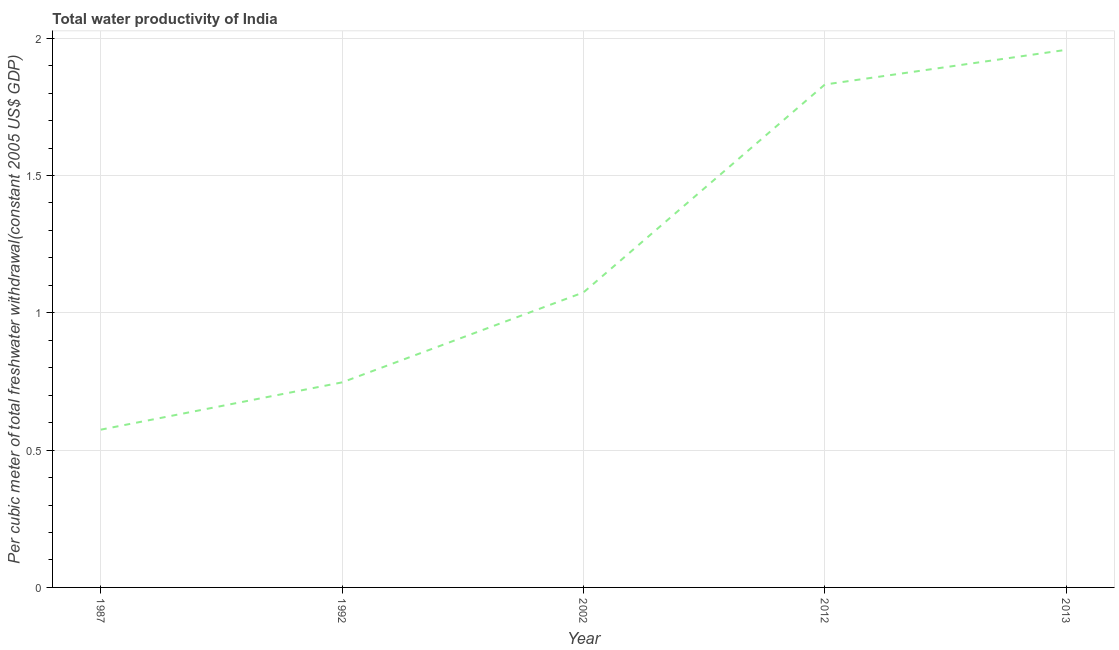What is the total water productivity in 2002?
Offer a very short reply. 1.07. Across all years, what is the maximum total water productivity?
Your answer should be compact. 1.96. Across all years, what is the minimum total water productivity?
Offer a terse response. 0.57. In which year was the total water productivity maximum?
Your answer should be compact. 2013. What is the sum of the total water productivity?
Provide a short and direct response. 6.18. What is the difference between the total water productivity in 2002 and 2012?
Provide a short and direct response. -0.76. What is the average total water productivity per year?
Your response must be concise. 1.24. What is the median total water productivity?
Offer a terse response. 1.07. In how many years, is the total water productivity greater than 1.8 US$?
Ensure brevity in your answer.  2. Do a majority of the years between 2012 and 1992 (inclusive) have total water productivity greater than 1.1 US$?
Make the answer very short. No. What is the ratio of the total water productivity in 1987 to that in 1992?
Offer a very short reply. 0.77. Is the total water productivity in 1992 less than that in 2012?
Ensure brevity in your answer.  Yes. What is the difference between the highest and the second highest total water productivity?
Ensure brevity in your answer.  0.13. What is the difference between the highest and the lowest total water productivity?
Offer a very short reply. 1.38. In how many years, is the total water productivity greater than the average total water productivity taken over all years?
Offer a terse response. 2. How many lines are there?
Provide a succinct answer. 1. How many years are there in the graph?
Make the answer very short. 5. What is the difference between two consecutive major ticks on the Y-axis?
Ensure brevity in your answer.  0.5. Are the values on the major ticks of Y-axis written in scientific E-notation?
Provide a succinct answer. No. Does the graph contain grids?
Your answer should be very brief. Yes. What is the title of the graph?
Your answer should be very brief. Total water productivity of India. What is the label or title of the Y-axis?
Make the answer very short. Per cubic meter of total freshwater withdrawal(constant 2005 US$ GDP). What is the Per cubic meter of total freshwater withdrawal(constant 2005 US$ GDP) in 1987?
Offer a terse response. 0.57. What is the Per cubic meter of total freshwater withdrawal(constant 2005 US$ GDP) in 1992?
Your answer should be compact. 0.75. What is the Per cubic meter of total freshwater withdrawal(constant 2005 US$ GDP) of 2002?
Your answer should be very brief. 1.07. What is the Per cubic meter of total freshwater withdrawal(constant 2005 US$ GDP) of 2012?
Give a very brief answer. 1.83. What is the Per cubic meter of total freshwater withdrawal(constant 2005 US$ GDP) of 2013?
Give a very brief answer. 1.96. What is the difference between the Per cubic meter of total freshwater withdrawal(constant 2005 US$ GDP) in 1987 and 1992?
Ensure brevity in your answer.  -0.17. What is the difference between the Per cubic meter of total freshwater withdrawal(constant 2005 US$ GDP) in 1987 and 2002?
Offer a terse response. -0.5. What is the difference between the Per cubic meter of total freshwater withdrawal(constant 2005 US$ GDP) in 1987 and 2012?
Your answer should be very brief. -1.26. What is the difference between the Per cubic meter of total freshwater withdrawal(constant 2005 US$ GDP) in 1987 and 2013?
Make the answer very short. -1.38. What is the difference between the Per cubic meter of total freshwater withdrawal(constant 2005 US$ GDP) in 1992 and 2002?
Keep it short and to the point. -0.33. What is the difference between the Per cubic meter of total freshwater withdrawal(constant 2005 US$ GDP) in 1992 and 2012?
Provide a succinct answer. -1.08. What is the difference between the Per cubic meter of total freshwater withdrawal(constant 2005 US$ GDP) in 1992 and 2013?
Your answer should be very brief. -1.21. What is the difference between the Per cubic meter of total freshwater withdrawal(constant 2005 US$ GDP) in 2002 and 2012?
Keep it short and to the point. -0.76. What is the difference between the Per cubic meter of total freshwater withdrawal(constant 2005 US$ GDP) in 2002 and 2013?
Your answer should be compact. -0.88. What is the difference between the Per cubic meter of total freshwater withdrawal(constant 2005 US$ GDP) in 2012 and 2013?
Your response must be concise. -0.13. What is the ratio of the Per cubic meter of total freshwater withdrawal(constant 2005 US$ GDP) in 1987 to that in 1992?
Offer a very short reply. 0.77. What is the ratio of the Per cubic meter of total freshwater withdrawal(constant 2005 US$ GDP) in 1987 to that in 2002?
Make the answer very short. 0.54. What is the ratio of the Per cubic meter of total freshwater withdrawal(constant 2005 US$ GDP) in 1987 to that in 2012?
Provide a succinct answer. 0.31. What is the ratio of the Per cubic meter of total freshwater withdrawal(constant 2005 US$ GDP) in 1987 to that in 2013?
Offer a very short reply. 0.29. What is the ratio of the Per cubic meter of total freshwater withdrawal(constant 2005 US$ GDP) in 1992 to that in 2002?
Provide a short and direct response. 0.69. What is the ratio of the Per cubic meter of total freshwater withdrawal(constant 2005 US$ GDP) in 1992 to that in 2012?
Offer a very short reply. 0.41. What is the ratio of the Per cubic meter of total freshwater withdrawal(constant 2005 US$ GDP) in 1992 to that in 2013?
Your answer should be very brief. 0.38. What is the ratio of the Per cubic meter of total freshwater withdrawal(constant 2005 US$ GDP) in 2002 to that in 2012?
Give a very brief answer. 0.59. What is the ratio of the Per cubic meter of total freshwater withdrawal(constant 2005 US$ GDP) in 2002 to that in 2013?
Offer a terse response. 0.55. What is the ratio of the Per cubic meter of total freshwater withdrawal(constant 2005 US$ GDP) in 2012 to that in 2013?
Offer a very short reply. 0.94. 